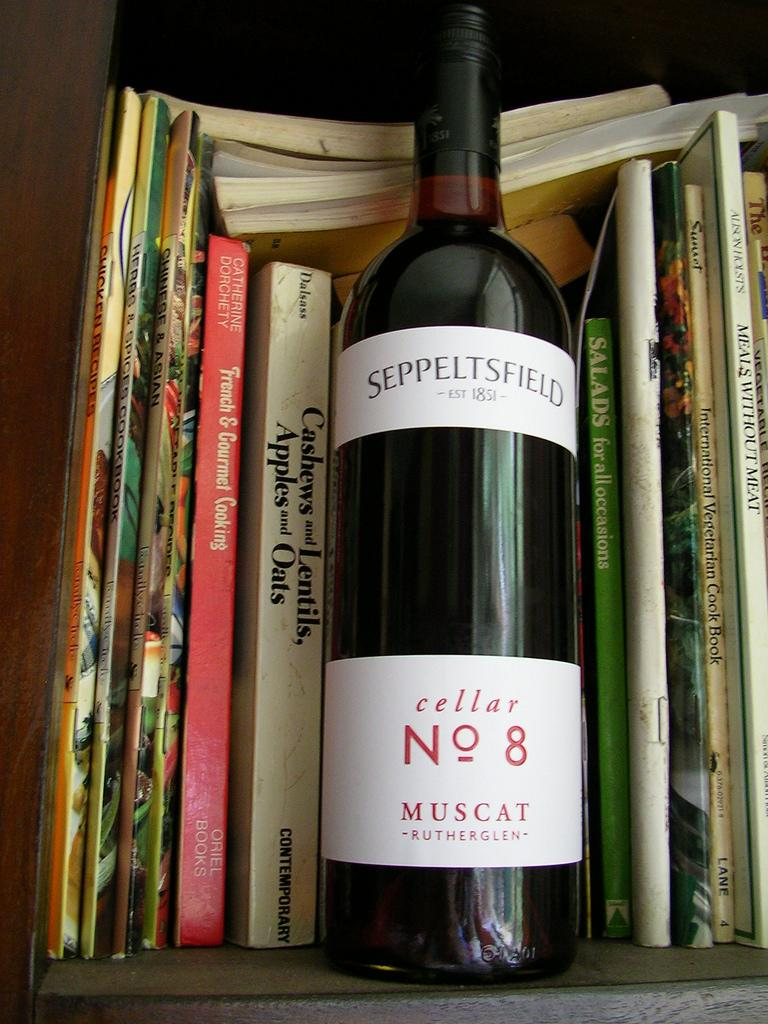<image>
Write a terse but informative summary of the picture. A bottle of cellar No 8 sits on a shelf with some books. 